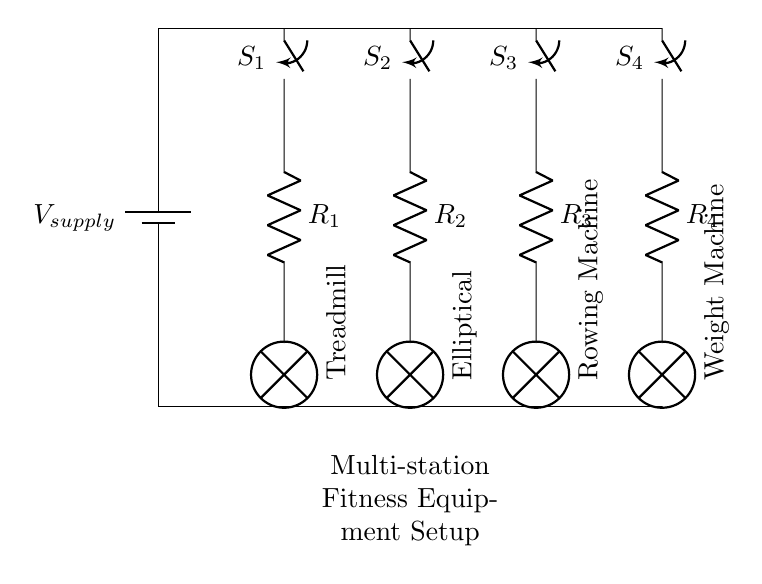What type of circuit is this? This circuit is a parallel circuit, as the components are connected across the same voltage source, allowing multiple paths for current.
Answer: Parallel How many switches are in the circuit? There are four switches visible in the circuit, each one controlling the power to a different piece of fitness equipment.
Answer: Four What does the resistor R1 represent? Resistor R1 corresponds to the electrical resistance in the circuit connected to the treadmill, indicating how much current flows when powered.
Answer: Treadmill resistance What is the total number of fitness equipment stations? The circuit diagram shows four distinct pieces of fitness equipment, each controlled separately by a switch.
Answer: Four If switch S2 is closed, what equipment will be powered? Closing switch S2 will power the elliptical machine, indicated by its position in the circuit below the switch.
Answer: Elliptical Which components are directly connected to the power supply? All four switches (S1, S2, S3, S4) are directly connected to the power supply at the top of the circuit diagram.
Answer: Four switches What happens to the other equipment if one switch is opened? Opening one switch will turn off the corresponding equipment but will not affect the others, as they are connected in parallel.
Answer: Remaining powered 